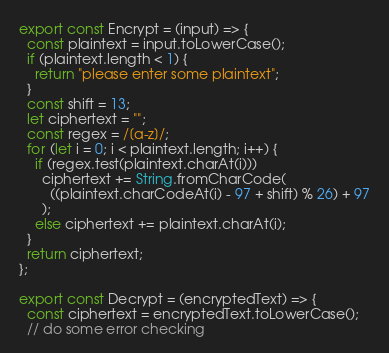<code> <loc_0><loc_0><loc_500><loc_500><_JavaScript_>export const Encrypt = (input) => {
  const plaintext = input.toLowerCase();
  if (plaintext.length < 1) {
    return "please enter some plaintext";
  }
  const shift = 13;
  let ciphertext = "";
  const regex = /[a-z]/;
  for (let i = 0; i < plaintext.length; i++) {
    if (regex.test(plaintext.charAt(i)))
      ciphertext += String.fromCharCode(
        ((plaintext.charCodeAt(i) - 97 + shift) % 26) + 97
      );
    else ciphertext += plaintext.charAt(i);
  }
  return ciphertext;
};

export const Decrypt = (encryptedText) => {
  const ciphertext = encryptedText.toLowerCase();
  // do some error checking</code> 